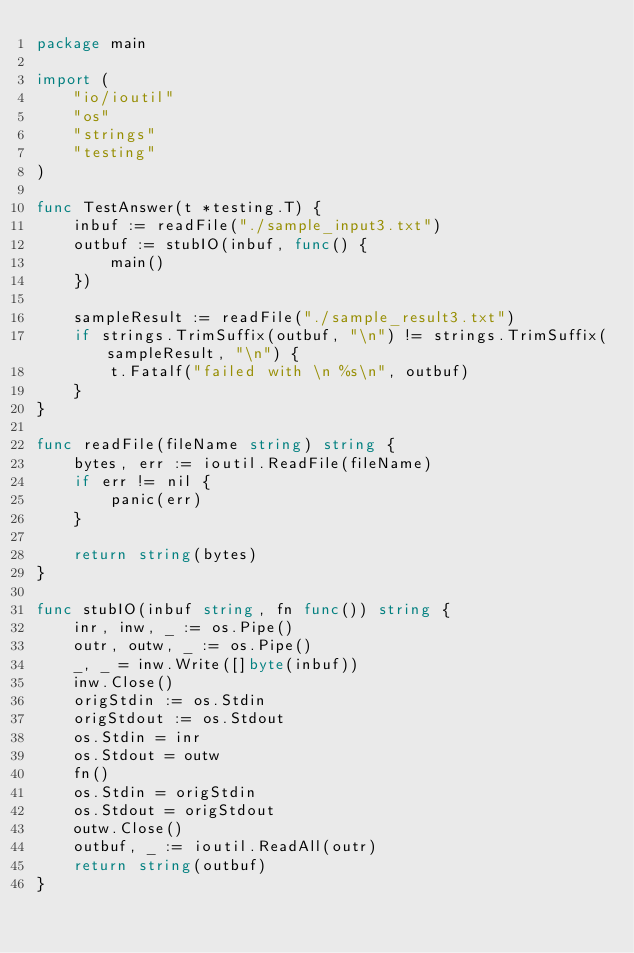<code> <loc_0><loc_0><loc_500><loc_500><_Go_>package main

import (
	"io/ioutil"
	"os"
	"strings"
	"testing"
)

func TestAnswer(t *testing.T) {
    inbuf := readFile("./sample_input3.txt")
    outbuf := stubIO(inbuf, func() {
        main()
    })

    sampleResult := readFile("./sample_result3.txt")
    if strings.TrimSuffix(outbuf, "\n") != strings.TrimSuffix(sampleResult, "\n") {
        t.Fatalf("failed with \n %s\n", outbuf)
    }
}

func readFile(fileName string) string {
    bytes, err := ioutil.ReadFile(fileName)
    if err != nil {
        panic(err)
    }

    return string(bytes)
}

func stubIO(inbuf string, fn func()) string {
    inr, inw, _ := os.Pipe()
    outr, outw, _ := os.Pipe()
    _, _ = inw.Write([]byte(inbuf))
    inw.Close()
    origStdin := os.Stdin
    origStdout := os.Stdout
	os.Stdin = inr
    os.Stdout = outw
    fn()
    os.Stdin = origStdin
    os.Stdout = origStdout
    outw.Close()
    outbuf, _ := ioutil.ReadAll(outr)
    return string(outbuf)
}</code> 